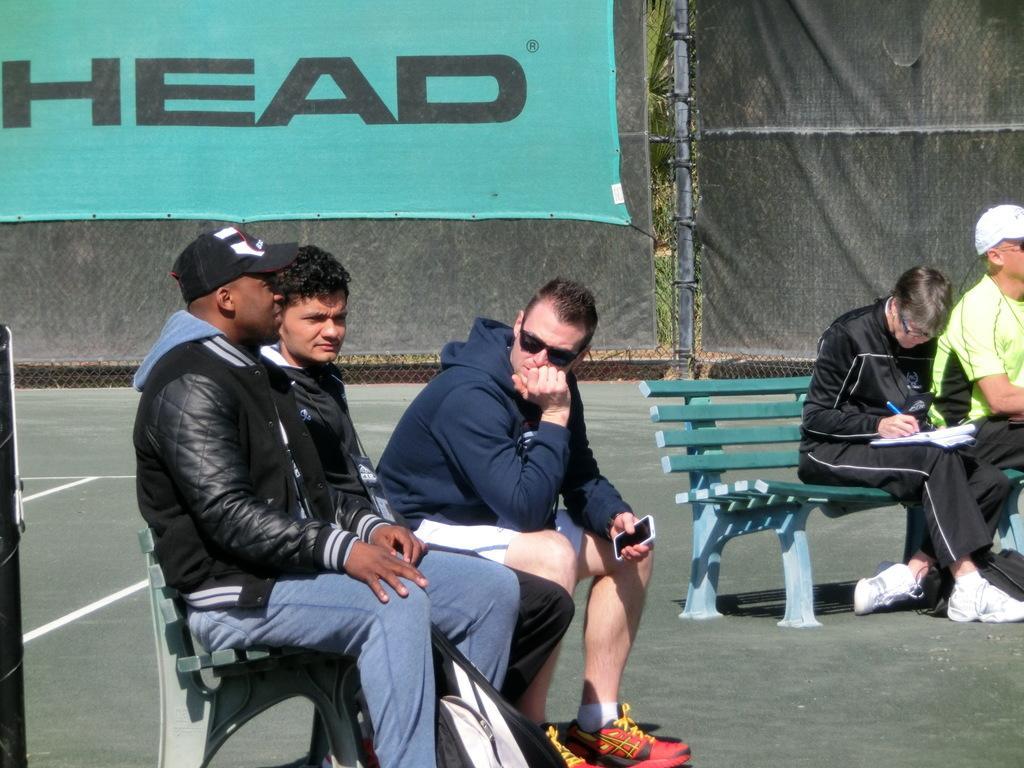Could you give a brief overview of what you see in this image? In this image there are people, benches, banners, mesh and objects. People are sitting on benches. Among them one person is holding a mobile and another person is holding an object. Something is written on the banner. 